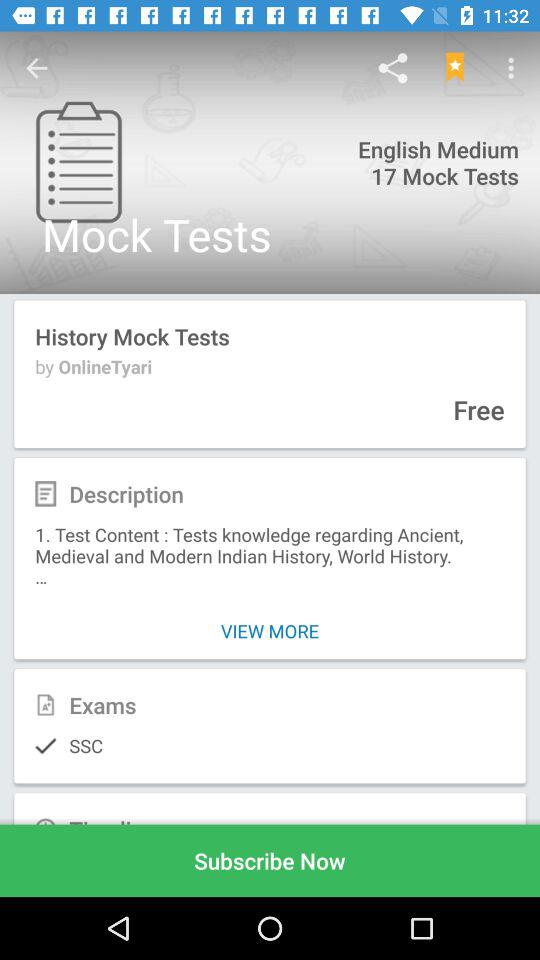Which option is selected in the exam category? The selected option is "SSC". 